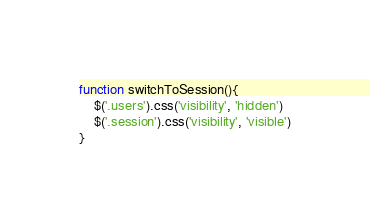Convert code to text. <code><loc_0><loc_0><loc_500><loc_500><_JavaScript_>function switchToSession(){
    $('.users').css('visibility', 'hidden')
    $('.session').css('visibility', 'visible')
}</code> 